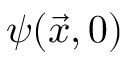<formula> <loc_0><loc_0><loc_500><loc_500>\psi ( \vec { x } , 0 )</formula> 